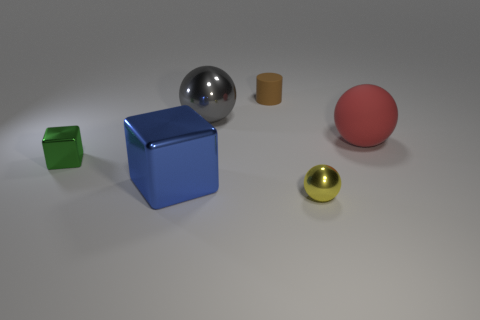Add 3 large red rubber objects. How many objects exist? 9 Subtract all cylinders. How many objects are left? 5 Add 6 green rubber things. How many green rubber things exist? 6 Subtract 0 gray cylinders. How many objects are left? 6 Subtract all cyan cylinders. Subtract all small shiny things. How many objects are left? 4 Add 3 big red things. How many big red things are left? 4 